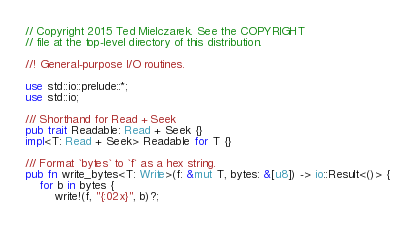Convert code to text. <code><loc_0><loc_0><loc_500><loc_500><_Rust_>// Copyright 2015 Ted Mielczarek. See the COPYRIGHT
// file at the top-level directory of this distribution.

//! General-purpose I/O routines.

use std::io::prelude::*;
use std::io;

/// Shorthand for Read + Seek
pub trait Readable: Read + Seek {}
impl<T: Read + Seek> Readable for T {}

/// Format `bytes` to `f` as a hex string.
pub fn write_bytes<T: Write>(f: &mut T, bytes: &[u8]) -> io::Result<()> {
    for b in bytes {
        write!(f, "{:02x}", b)?;</code> 